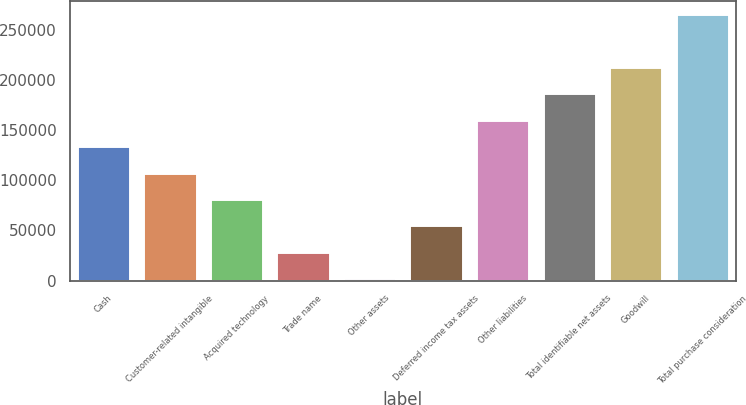<chart> <loc_0><loc_0><loc_500><loc_500><bar_chart><fcel>Cash<fcel>Customer-related intangible<fcel>Acquired technology<fcel>Trade name<fcel>Other assets<fcel>Deferred income tax assets<fcel>Other liabilities<fcel>Total identifiable net assets<fcel>Goodwill<fcel>Total purchase consideration<nl><fcel>134160<fcel>107795<fcel>81430.5<fcel>28701.5<fcel>2337<fcel>55066<fcel>160524<fcel>186888<fcel>213253<fcel>265982<nl></chart> 